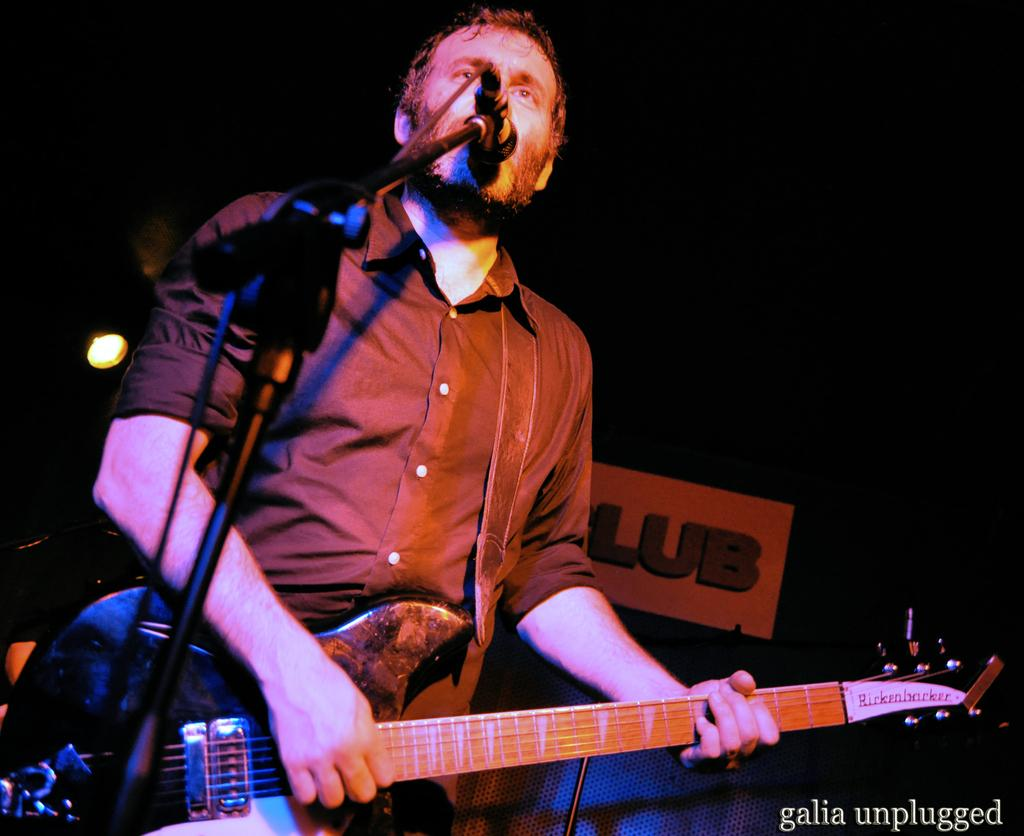What is the person holding in the image? The person is holding a guitar. What can be seen near the person in the image? The person is standing in front of a microphone. What is used to hold the microphone in place? There is a microphone holder in the image. What is visible in the background of the image? There is a board with a pole in the background. What type of drug can be seen in the person's hand in the image? There is no drug present in the image; the person is holding a guitar. How many matches are visible in the person's pocket in the image? There are no matches visible in the image. 